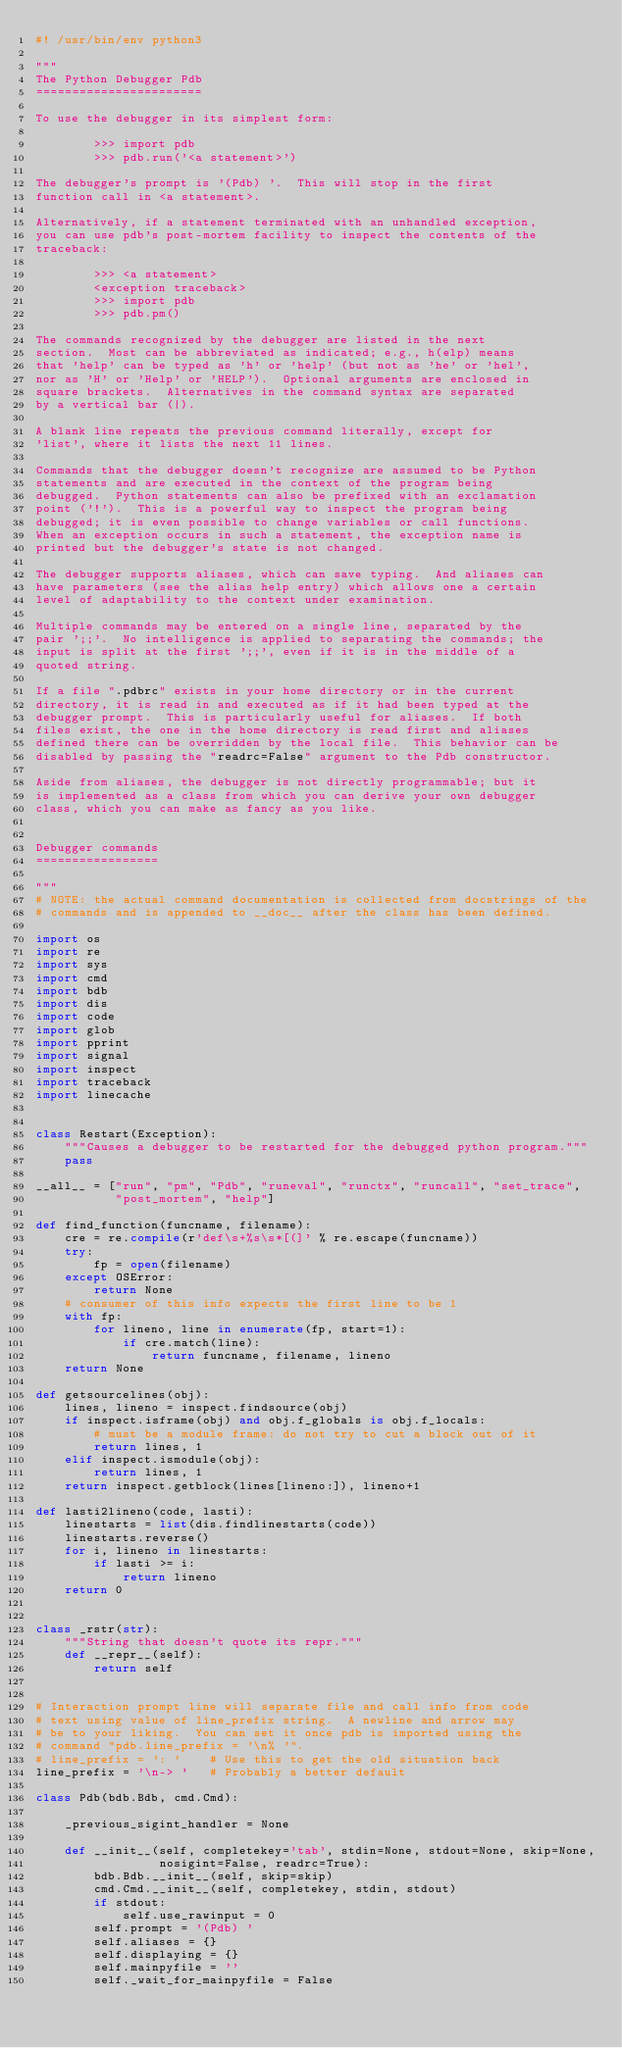Convert code to text. <code><loc_0><loc_0><loc_500><loc_500><_Python_>#! /usr/bin/env python3

"""
The Python Debugger Pdb
=======================

To use the debugger in its simplest form:

        >>> import pdb
        >>> pdb.run('<a statement>')

The debugger's prompt is '(Pdb) '.  This will stop in the first
function call in <a statement>.

Alternatively, if a statement terminated with an unhandled exception,
you can use pdb's post-mortem facility to inspect the contents of the
traceback:

        >>> <a statement>
        <exception traceback>
        >>> import pdb
        >>> pdb.pm()

The commands recognized by the debugger are listed in the next
section.  Most can be abbreviated as indicated; e.g., h(elp) means
that 'help' can be typed as 'h' or 'help' (but not as 'he' or 'hel',
nor as 'H' or 'Help' or 'HELP').  Optional arguments are enclosed in
square brackets.  Alternatives in the command syntax are separated
by a vertical bar (|).

A blank line repeats the previous command literally, except for
'list', where it lists the next 11 lines.

Commands that the debugger doesn't recognize are assumed to be Python
statements and are executed in the context of the program being
debugged.  Python statements can also be prefixed with an exclamation
point ('!').  This is a powerful way to inspect the program being
debugged; it is even possible to change variables or call functions.
When an exception occurs in such a statement, the exception name is
printed but the debugger's state is not changed.

The debugger supports aliases, which can save typing.  And aliases can
have parameters (see the alias help entry) which allows one a certain
level of adaptability to the context under examination.

Multiple commands may be entered on a single line, separated by the
pair ';;'.  No intelligence is applied to separating the commands; the
input is split at the first ';;', even if it is in the middle of a
quoted string.

If a file ".pdbrc" exists in your home directory or in the current
directory, it is read in and executed as if it had been typed at the
debugger prompt.  This is particularly useful for aliases.  If both
files exist, the one in the home directory is read first and aliases
defined there can be overridden by the local file.  This behavior can be
disabled by passing the "readrc=False" argument to the Pdb constructor.

Aside from aliases, the debugger is not directly programmable; but it
is implemented as a class from which you can derive your own debugger
class, which you can make as fancy as you like.


Debugger commands
=================

"""
# NOTE: the actual command documentation is collected from docstrings of the
# commands and is appended to __doc__ after the class has been defined.

import os
import re
import sys
import cmd
import bdb
import dis
import code
import glob
import pprint
import signal
import inspect
import traceback
import linecache


class Restart(Exception):
    """Causes a debugger to be restarted for the debugged python program."""
    pass

__all__ = ["run", "pm", "Pdb", "runeval", "runctx", "runcall", "set_trace",
           "post_mortem", "help"]

def find_function(funcname, filename):
    cre = re.compile(r'def\s+%s\s*[(]' % re.escape(funcname))
    try:
        fp = open(filename)
    except OSError:
        return None
    # consumer of this info expects the first line to be 1
    with fp:
        for lineno, line in enumerate(fp, start=1):
            if cre.match(line):
                return funcname, filename, lineno
    return None

def getsourcelines(obj):
    lines, lineno = inspect.findsource(obj)
    if inspect.isframe(obj) and obj.f_globals is obj.f_locals:
        # must be a module frame: do not try to cut a block out of it
        return lines, 1
    elif inspect.ismodule(obj):
        return lines, 1
    return inspect.getblock(lines[lineno:]), lineno+1

def lasti2lineno(code, lasti):
    linestarts = list(dis.findlinestarts(code))
    linestarts.reverse()
    for i, lineno in linestarts:
        if lasti >= i:
            return lineno
    return 0


class _rstr(str):
    """String that doesn't quote its repr."""
    def __repr__(self):
        return self


# Interaction prompt line will separate file and call info from code
# text using value of line_prefix string.  A newline and arrow may
# be to your liking.  You can set it once pdb is imported using the
# command "pdb.line_prefix = '\n% '".
# line_prefix = ': '    # Use this to get the old situation back
line_prefix = '\n-> '   # Probably a better default

class Pdb(bdb.Bdb, cmd.Cmd):

    _previous_sigint_handler = None

    def __init__(self, completekey='tab', stdin=None, stdout=None, skip=None,
                 nosigint=False, readrc=True):
        bdb.Bdb.__init__(self, skip=skip)
        cmd.Cmd.__init__(self, completekey, stdin, stdout)
        if stdout:
            self.use_rawinput = 0
        self.prompt = '(Pdb) '
        self.aliases = {}
        self.displaying = {}
        self.mainpyfile = ''
        self._wait_for_mainpyfile = False</code> 